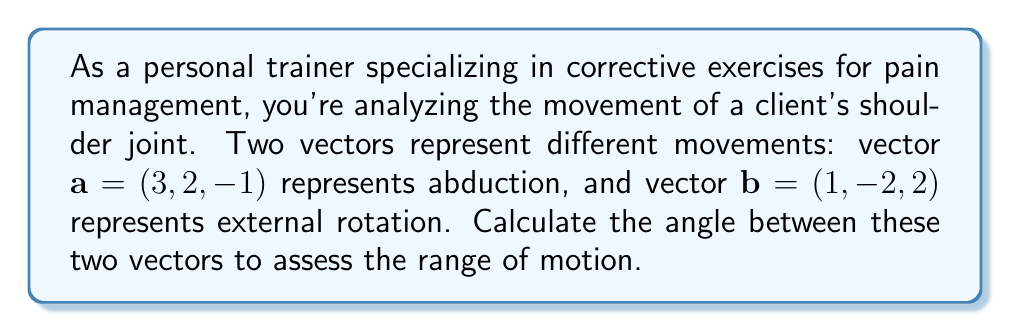Can you solve this math problem? To calculate the angle between two vectors, we can use the dot product formula:

$$\cos \theta = \frac{\mathbf{a} \cdot \mathbf{b}}{|\mathbf{a}||\mathbf{b}|}$$

Where $\theta$ is the angle between the vectors, $\mathbf{a} \cdot \mathbf{b}$ is the dot product, and $|\mathbf{a}|$ and $|\mathbf{b}|$ are the magnitudes of vectors $\mathbf{a}$ and $\mathbf{b}$ respectively.

Step 1: Calculate the dot product $\mathbf{a} \cdot \mathbf{b}$
$$\mathbf{a} \cdot \mathbf{b} = (3)(1) + (2)(-2) + (-1)(2) = 3 - 4 - 2 = -3$$

Step 2: Calculate the magnitudes of $\mathbf{a}$ and $\mathbf{b}$
$$|\mathbf{a}| = \sqrt{3^2 + 2^2 + (-1)^2} = \sqrt{14}$$
$$|\mathbf{b}| = \sqrt{1^2 + (-2)^2 + 2^2} = 3$$

Step 3: Substitute into the formula
$$\cos \theta = \frac{-3}{\sqrt{14} \cdot 3}$$

Step 4: Simplify
$$\cos \theta = -\frac{1}{\sqrt{14}}$$

Step 5: Take the inverse cosine (arccos) of both sides
$$\theta = \arccos\left(-\frac{1}{\sqrt{14}}\right)$$

Step 6: Calculate the result (in radians)
$$\theta \approx 1.8185 \text{ radians}$$

Step 7: Convert to degrees
$$\theta \approx 1.8185 \cdot \frac{180}{\pi} \approx 104.2°$$
Answer: The angle between the two vectors representing abduction and external rotation of the shoulder joint is approximately 104.2°. 